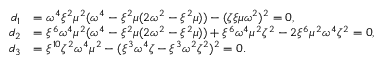<formula> <loc_0><loc_0><loc_500><loc_500>\begin{array} { r l } { d _ { 1 } } & { = \omega ^ { 4 } \xi ^ { 2 } \mu ^ { 2 } ( \omega ^ { 4 } - \xi ^ { 2 } \mu ( 2 \omega ^ { 2 } - \xi ^ { 2 } \mu ) ) - ( \zeta \xi \mu \omega ^ { 2 } ) ^ { 2 } = 0 , } \\ { d _ { 2 } } & { = \xi ^ { 6 } \omega ^ { 4 } \mu ^ { 2 } ( \omega ^ { 4 } - \xi ^ { 2 } \mu ( 2 \omega ^ { 2 } - \xi ^ { 2 } \mu ) ) + \xi ^ { 6 } \omega ^ { 4 } \mu ^ { 2 } \zeta ^ { 2 } - 2 \xi ^ { 6 } \mu ^ { 2 } \omega ^ { 4 } \zeta ^ { 2 } = 0 , } \\ { d _ { 3 } } & { = \xi ^ { 1 0 } \zeta ^ { 2 } \omega ^ { 4 } \mu ^ { 2 } - ( \xi ^ { 3 } \omega ^ { 4 } \zeta - \xi ^ { 3 } \omega ^ { 2 } \zeta ^ { 2 } ) ^ { 2 } = 0 . } \end{array}</formula> 